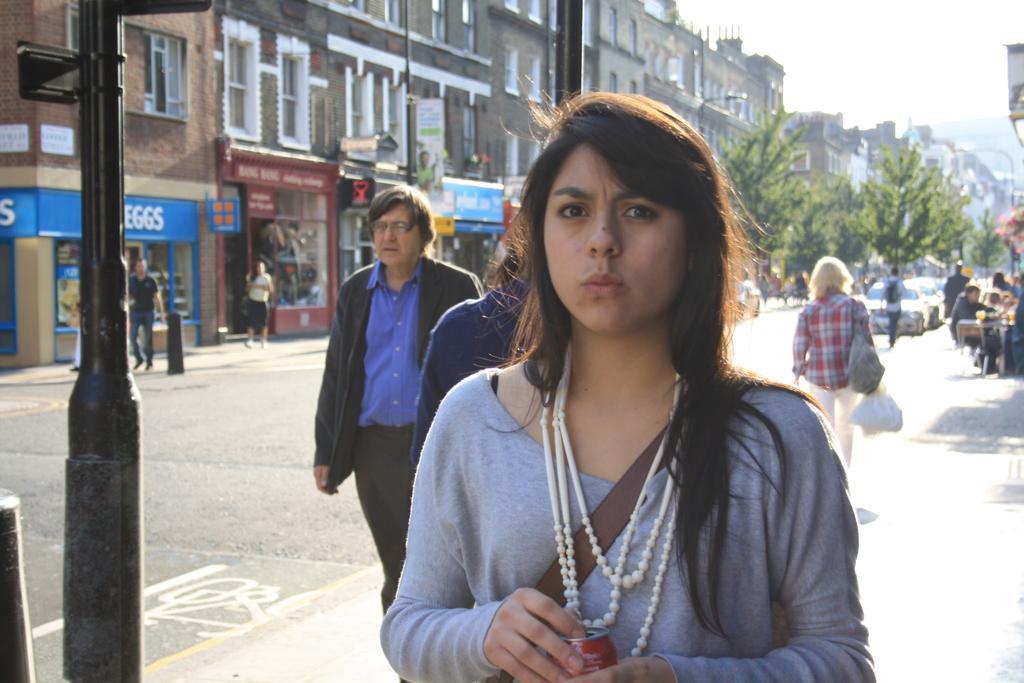In one or two sentences, can you explain what this image depicts? In the foreground of this image, there is a woman standing wearing a backpack and holding a tin. In the background, there are persons walking on the side path and few are sitting on the right. In the background, there are trees, buildings, few shops, persons walking on the side path, road and few vehicles. On the left, there is a pole and a bollard. On the top right, there is the sky. 